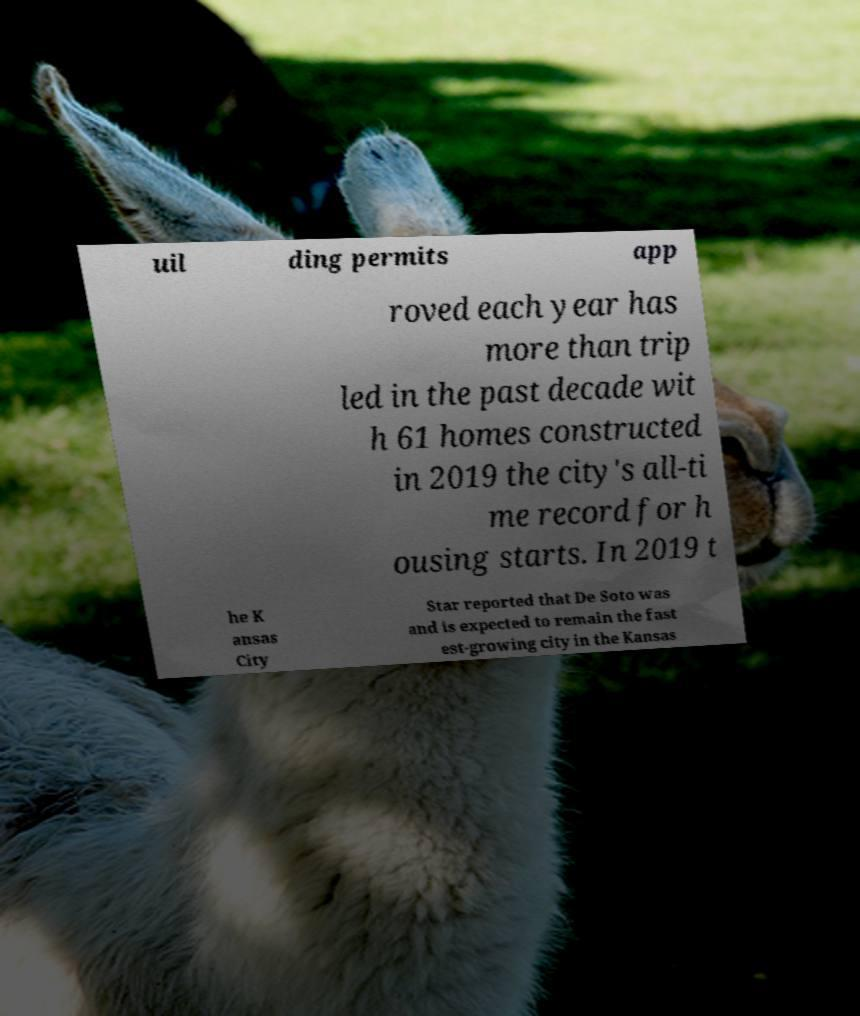Please read and relay the text visible in this image. What does it say? uil ding permits app roved each year has more than trip led in the past decade wit h 61 homes constructed in 2019 the city's all-ti me record for h ousing starts. In 2019 t he K ansas City Star reported that De Soto was and is expected to remain the fast est-growing city in the Kansas 